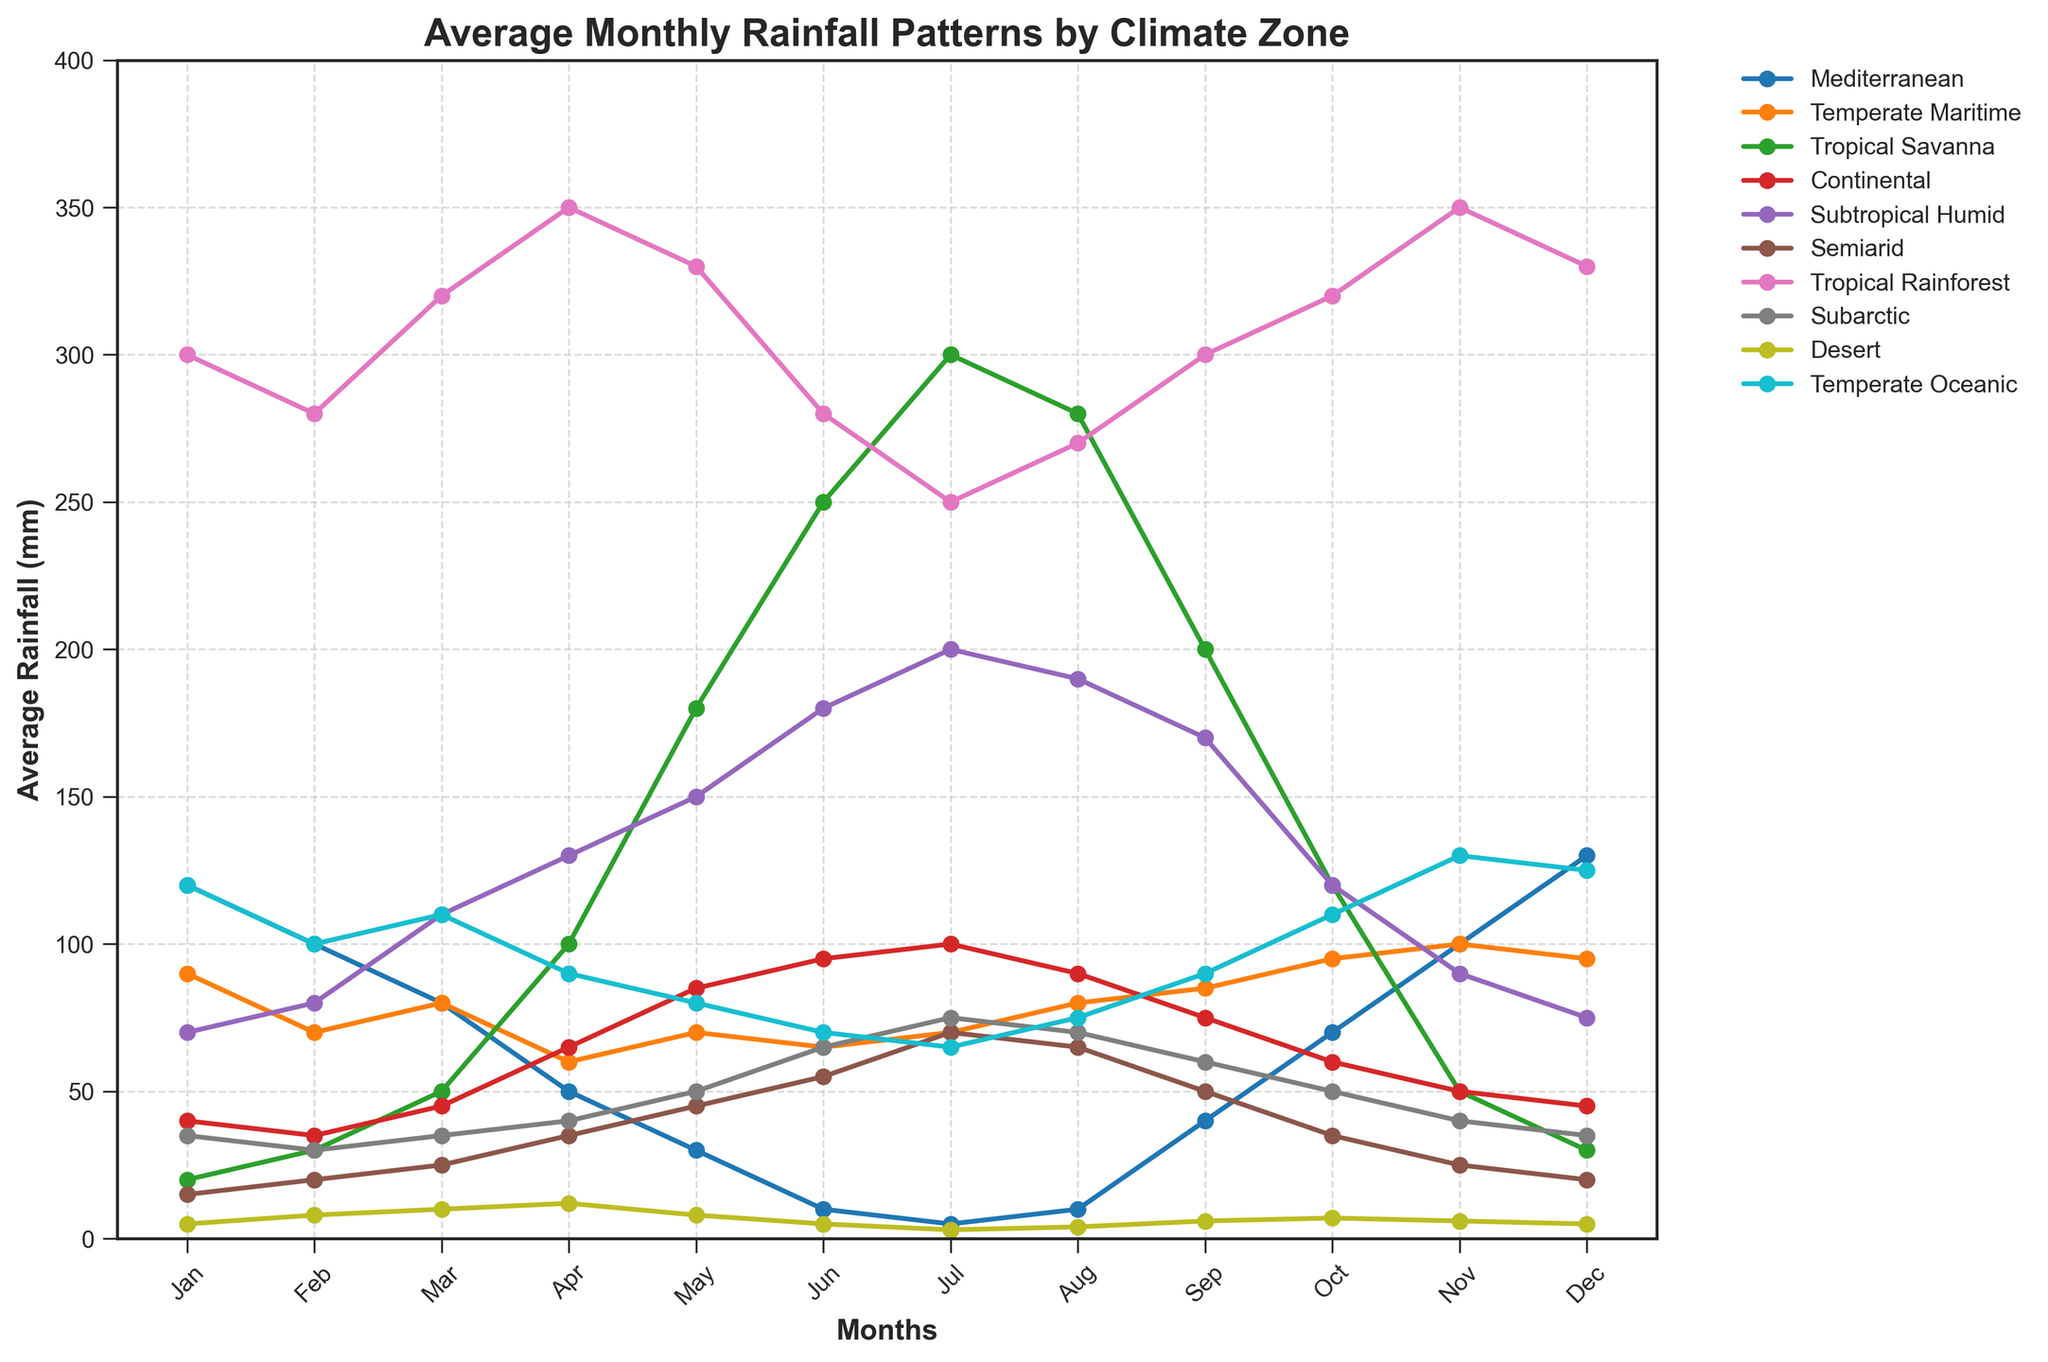What's the climate zone with the highest average rainfall in January? Look for the line that reaches the highest value on the y-axis in January. The Tropical Rainforest has the highest value at 300 mm.
Answer: Tropical Rainforest Which climate zone has the most pronounced increase in rainfall from May to June? Compare the differences between the May and June points for each climate zone. The Tropical Savanna increases from 180 mm to 250 mm, an increase of 70 mm.
Answer: Tropical Savanna How does the average rainfall in July for the Semiarid zone compare with the same month in the Mediterranean zone? Identify the July rainfall values for both zones. Semiarid has 70 mm, while Mediterranean has 5 mm.
Answer: Semiarid has more What's the total rainfall for the Subtropical Humid zone in the first half of the year (Jan-Jun)? Add the values from January to June for the Subtropical Humid zone: 70 + 80 + 110 + 130 + 150 + 180 = 720 mm.
Answer: 720 mm Which month has the least rainfall in the Temperate Oceanic zone? Identify the lowest point on the Temperate Oceanic line. July's value is the lowest with 65 mm.
Answer: July Compare the average rainfall in April between Continental and Subarctic zones? Look at the April values for both zones. Continental has 65 mm and Subarctic has 40 mm.
Answer: Continental has more What is the trend of rainfall in the Tropical Rainforest zone from January to December? Observe the direction and changes of the Tropical Rainforest line across months, it fluctuates but remains high throughout the year.
Answer: High and fluctuating How much more rainfall does the Desert zone experience in December compared to January? Subtract the January value from the December value for the Desert zone: 5 - 5 = 0 mm.
Answer: 0 mm Which climate zone exhibits the most consistent rainfall pattern throughout the year? Look for the line with the least variability. The Temperate Maritime line shows the least fluctuation.
Answer: Temperate Maritime In November, which climate zone receives similar rainfall to the Mediterranean zone? Compare the November values across zones. Mediterranean has 100 mm, and Temperate Maritime is close with 100 mm.
Answer: Temperate Maritime 